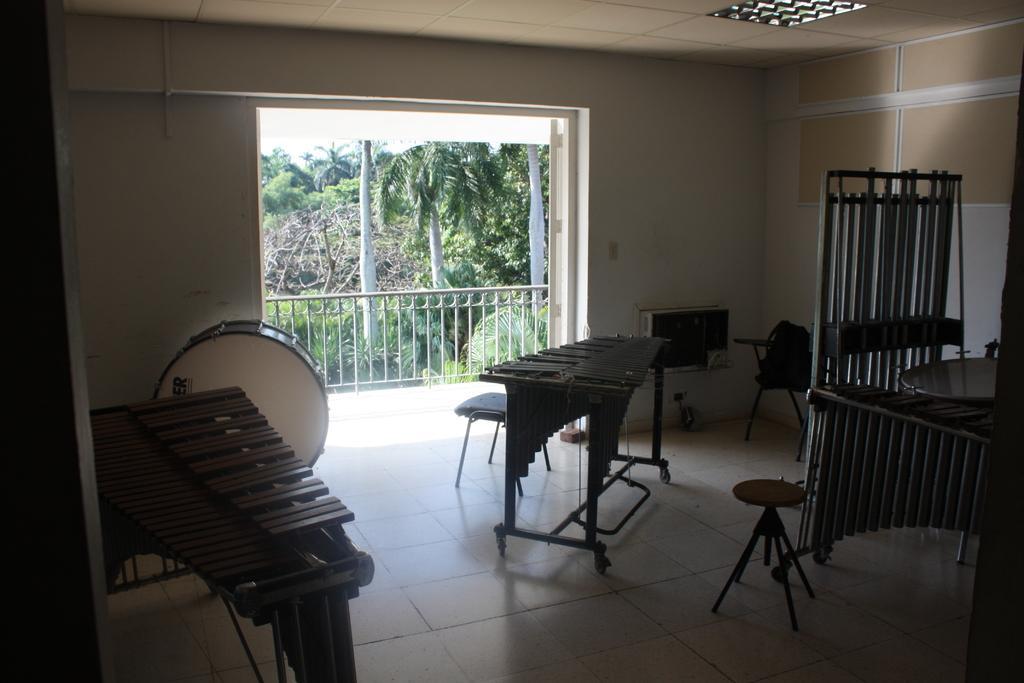Can you describe this image briefly? In this image we can see some musical instruments chairs benches and at the background of the image there is door, fencing and there are some trees. 